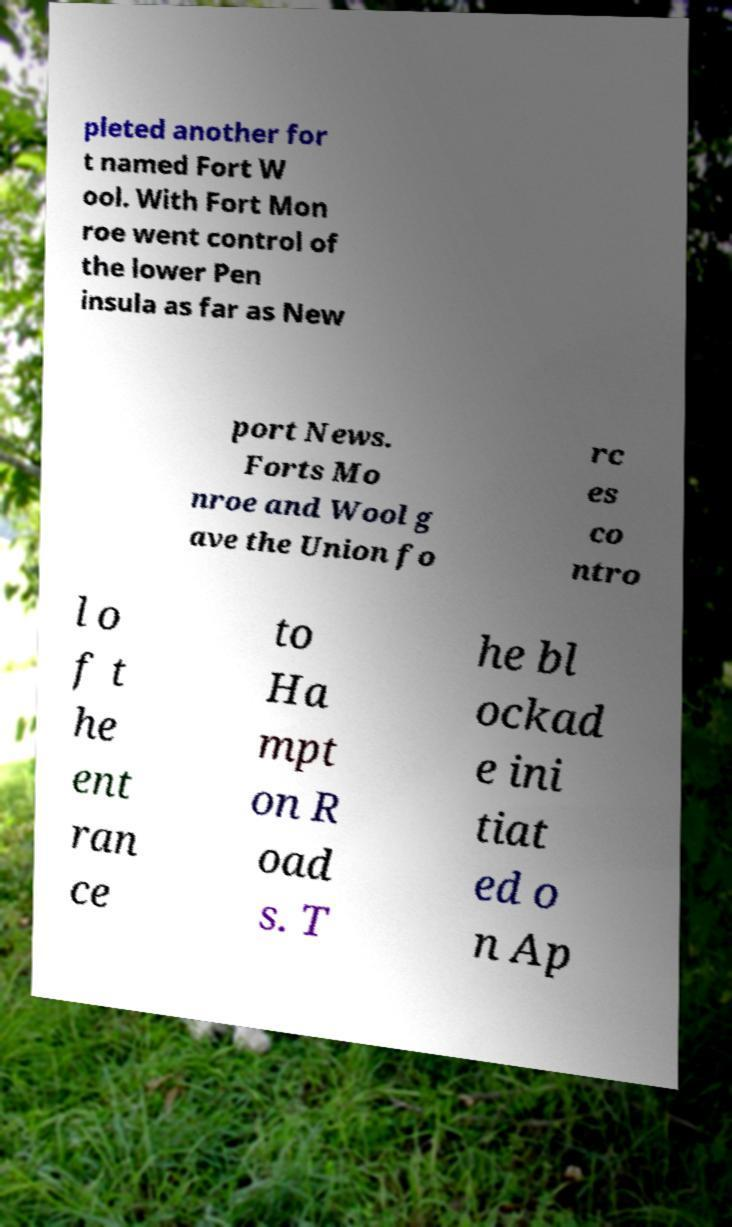I need the written content from this picture converted into text. Can you do that? pleted another for t named Fort W ool. With Fort Mon roe went control of the lower Pen insula as far as New port News. Forts Mo nroe and Wool g ave the Union fo rc es co ntro l o f t he ent ran ce to Ha mpt on R oad s. T he bl ockad e ini tiat ed o n Ap 